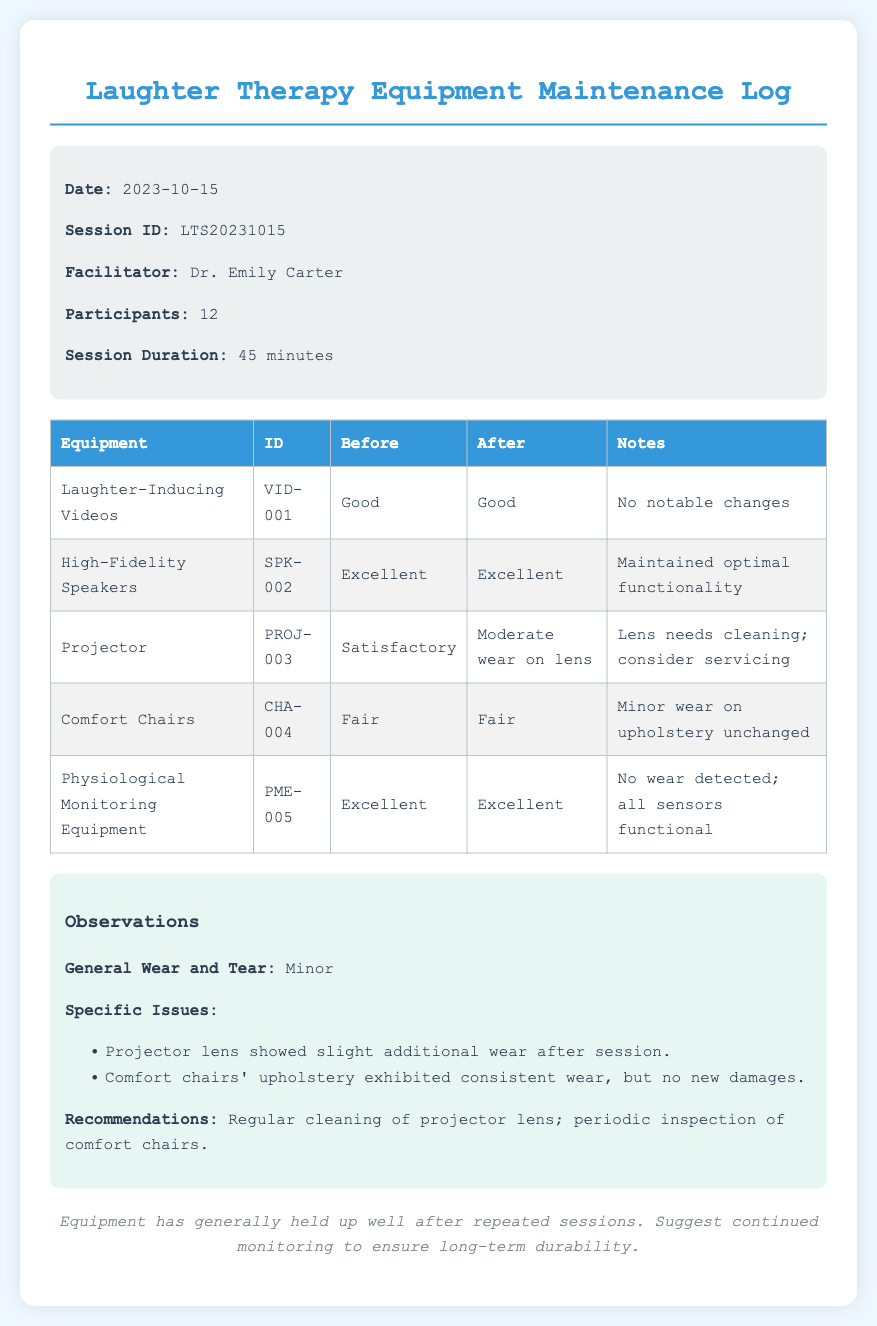What is the session ID? The session ID is presented in the session information as LTS20231015.
Answer: LTS20231015 Who is the facilitator? The facilitator's name is listed in the session information as Dr. Emily Carter.
Answer: Dr. Emily Carter How many participants were in the session? The number of participants is provided in the session information as 12.
Answer: 12 What was the condition of the projector before the session? The projector's condition before the session is noted as Satisfactory in the equipment table.
Answer: Satisfactory What recommendation is made regarding the projector? The recommendation provided in the observations section is to regularly clean the projector lens.
Answer: Regular cleaning of projector lens What wear was noted on the comfort chairs? The wear noted on the comfort chairs is described as minor wear on upholstery unchanged.
Answer: Minor wear on upholstery unchanged What is the general wear and tear assessment after the session? The general wear and tear assessment is indicated as Minor in the observations section.
Answer: Minor Which equipment had no wear detected? The physiological monitoring equipment is noted to have no wear detected after the session.
Answer: Physiological Monitoring Equipment What is the date of the session? The date of the session is specified in the session information as 2023-10-15.
Answer: 2023-10-15 